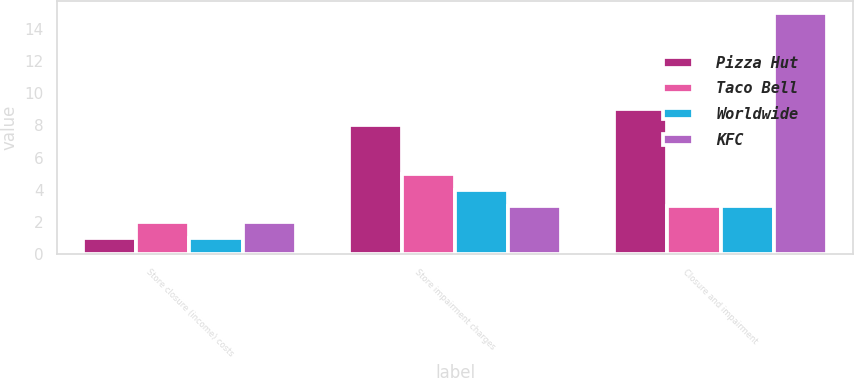<chart> <loc_0><loc_0><loc_500><loc_500><stacked_bar_chart><ecel><fcel>Store closure (income) costs<fcel>Store impairment charges<fcel>Closure and impairment<nl><fcel>Pizza Hut<fcel>1<fcel>8<fcel>9<nl><fcel>Taco Bell<fcel>2<fcel>5<fcel>3<nl><fcel>Worldwide<fcel>1<fcel>4<fcel>3<nl><fcel>KFC<fcel>2<fcel>3<fcel>15<nl></chart> 